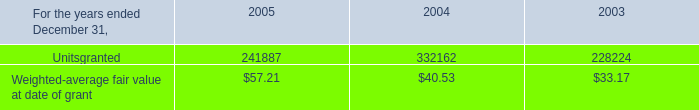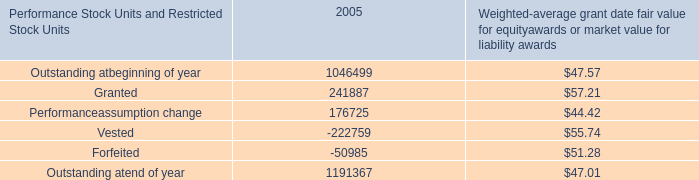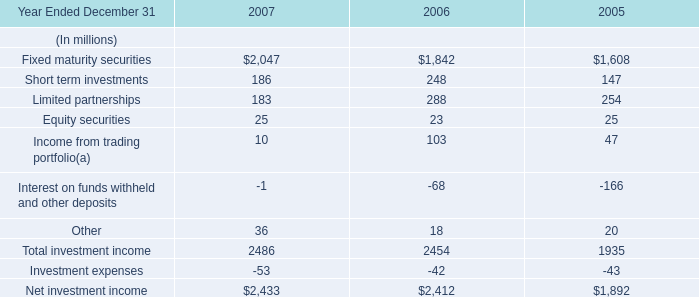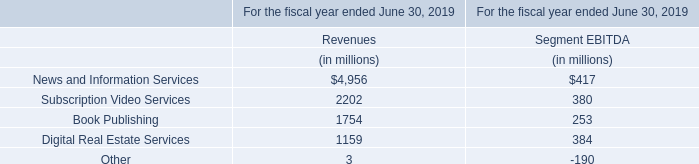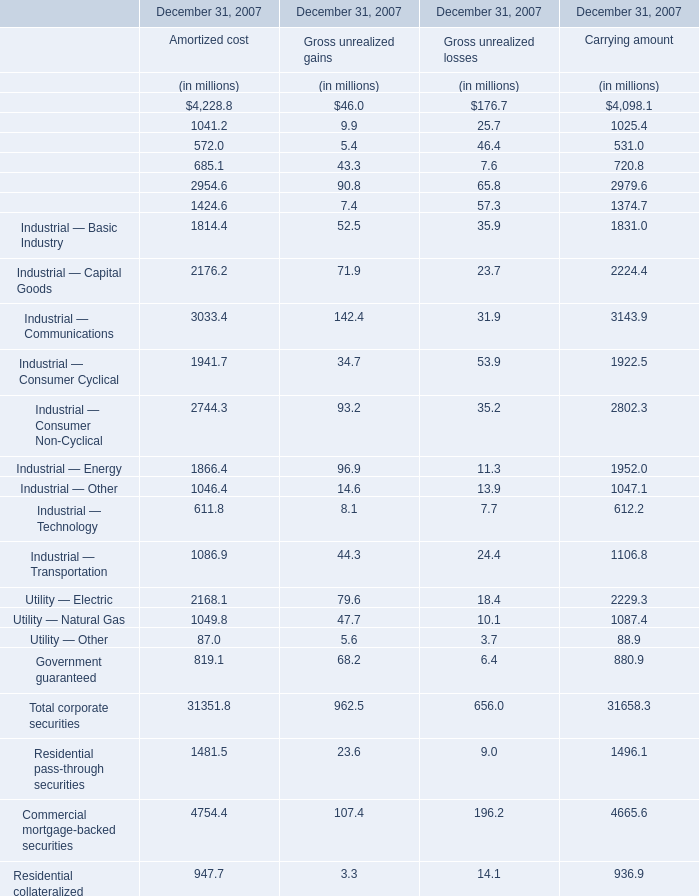what's the total amount of Finance — Brokerage of December 31, 2007 Carrying amount, and Net investment income of 2006 ? 
Computations: (1025.4 + 2412.0)
Answer: 3437.4. 